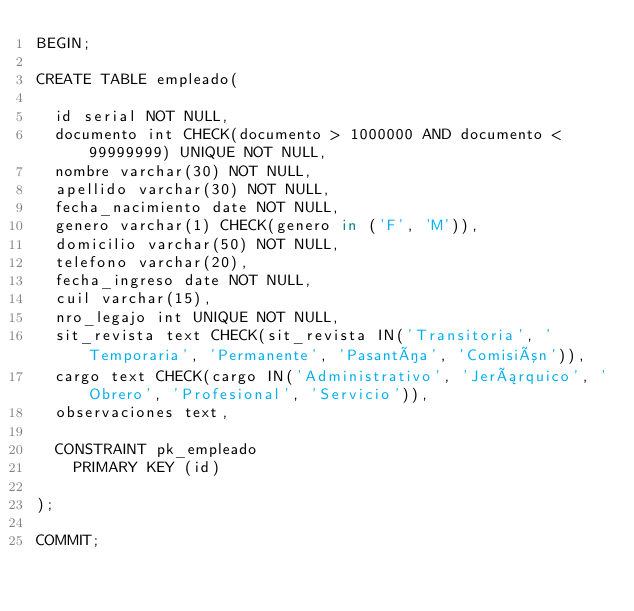<code> <loc_0><loc_0><loc_500><loc_500><_SQL_>BEGIN;

CREATE TABLE empleado(
	
	id serial NOT NULL,
	documento int CHECK(documento > 1000000 AND documento < 99999999) UNIQUE NOT NULL,
	nombre varchar(30) NOT NULL,
	apellido varchar(30) NOT NULL,
	fecha_nacimiento date NOT NULL,
	genero varchar(1) CHECK(genero in ('F', 'M')),
	domicilio varchar(50) NOT NULL,
	telefono varchar(20),
	fecha_ingreso date NOT NULL,
	cuil varchar(15),
	nro_legajo int UNIQUE NOT NULL,
	sit_revista text CHECK(sit_revista IN('Transitoria', 'Temporaria', 'Permanente', 'Pasantía', 'Comisión')),
	cargo text CHECK(cargo IN('Administrativo', 'Jerárquico', 'Obrero', 'Profesional', 'Servicio')),
	observaciones text,
	
	CONSTRAINT pk_empleado
		PRIMARY KEY (id)
	
);

COMMIT;
</code> 